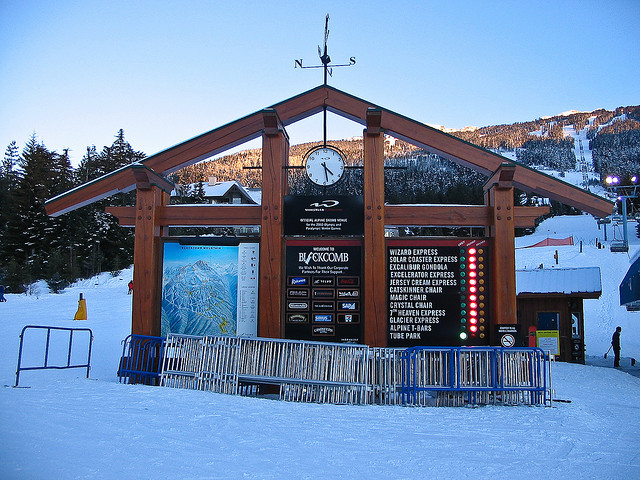<image>Where is this? I don't know exactly where this is. It could be a lodge, mountains, blackcomb, ski slope or ski resort. Where is this? I don't know where this is. It can be a lodge in the mountains or a ski resort on Blackcomb. 